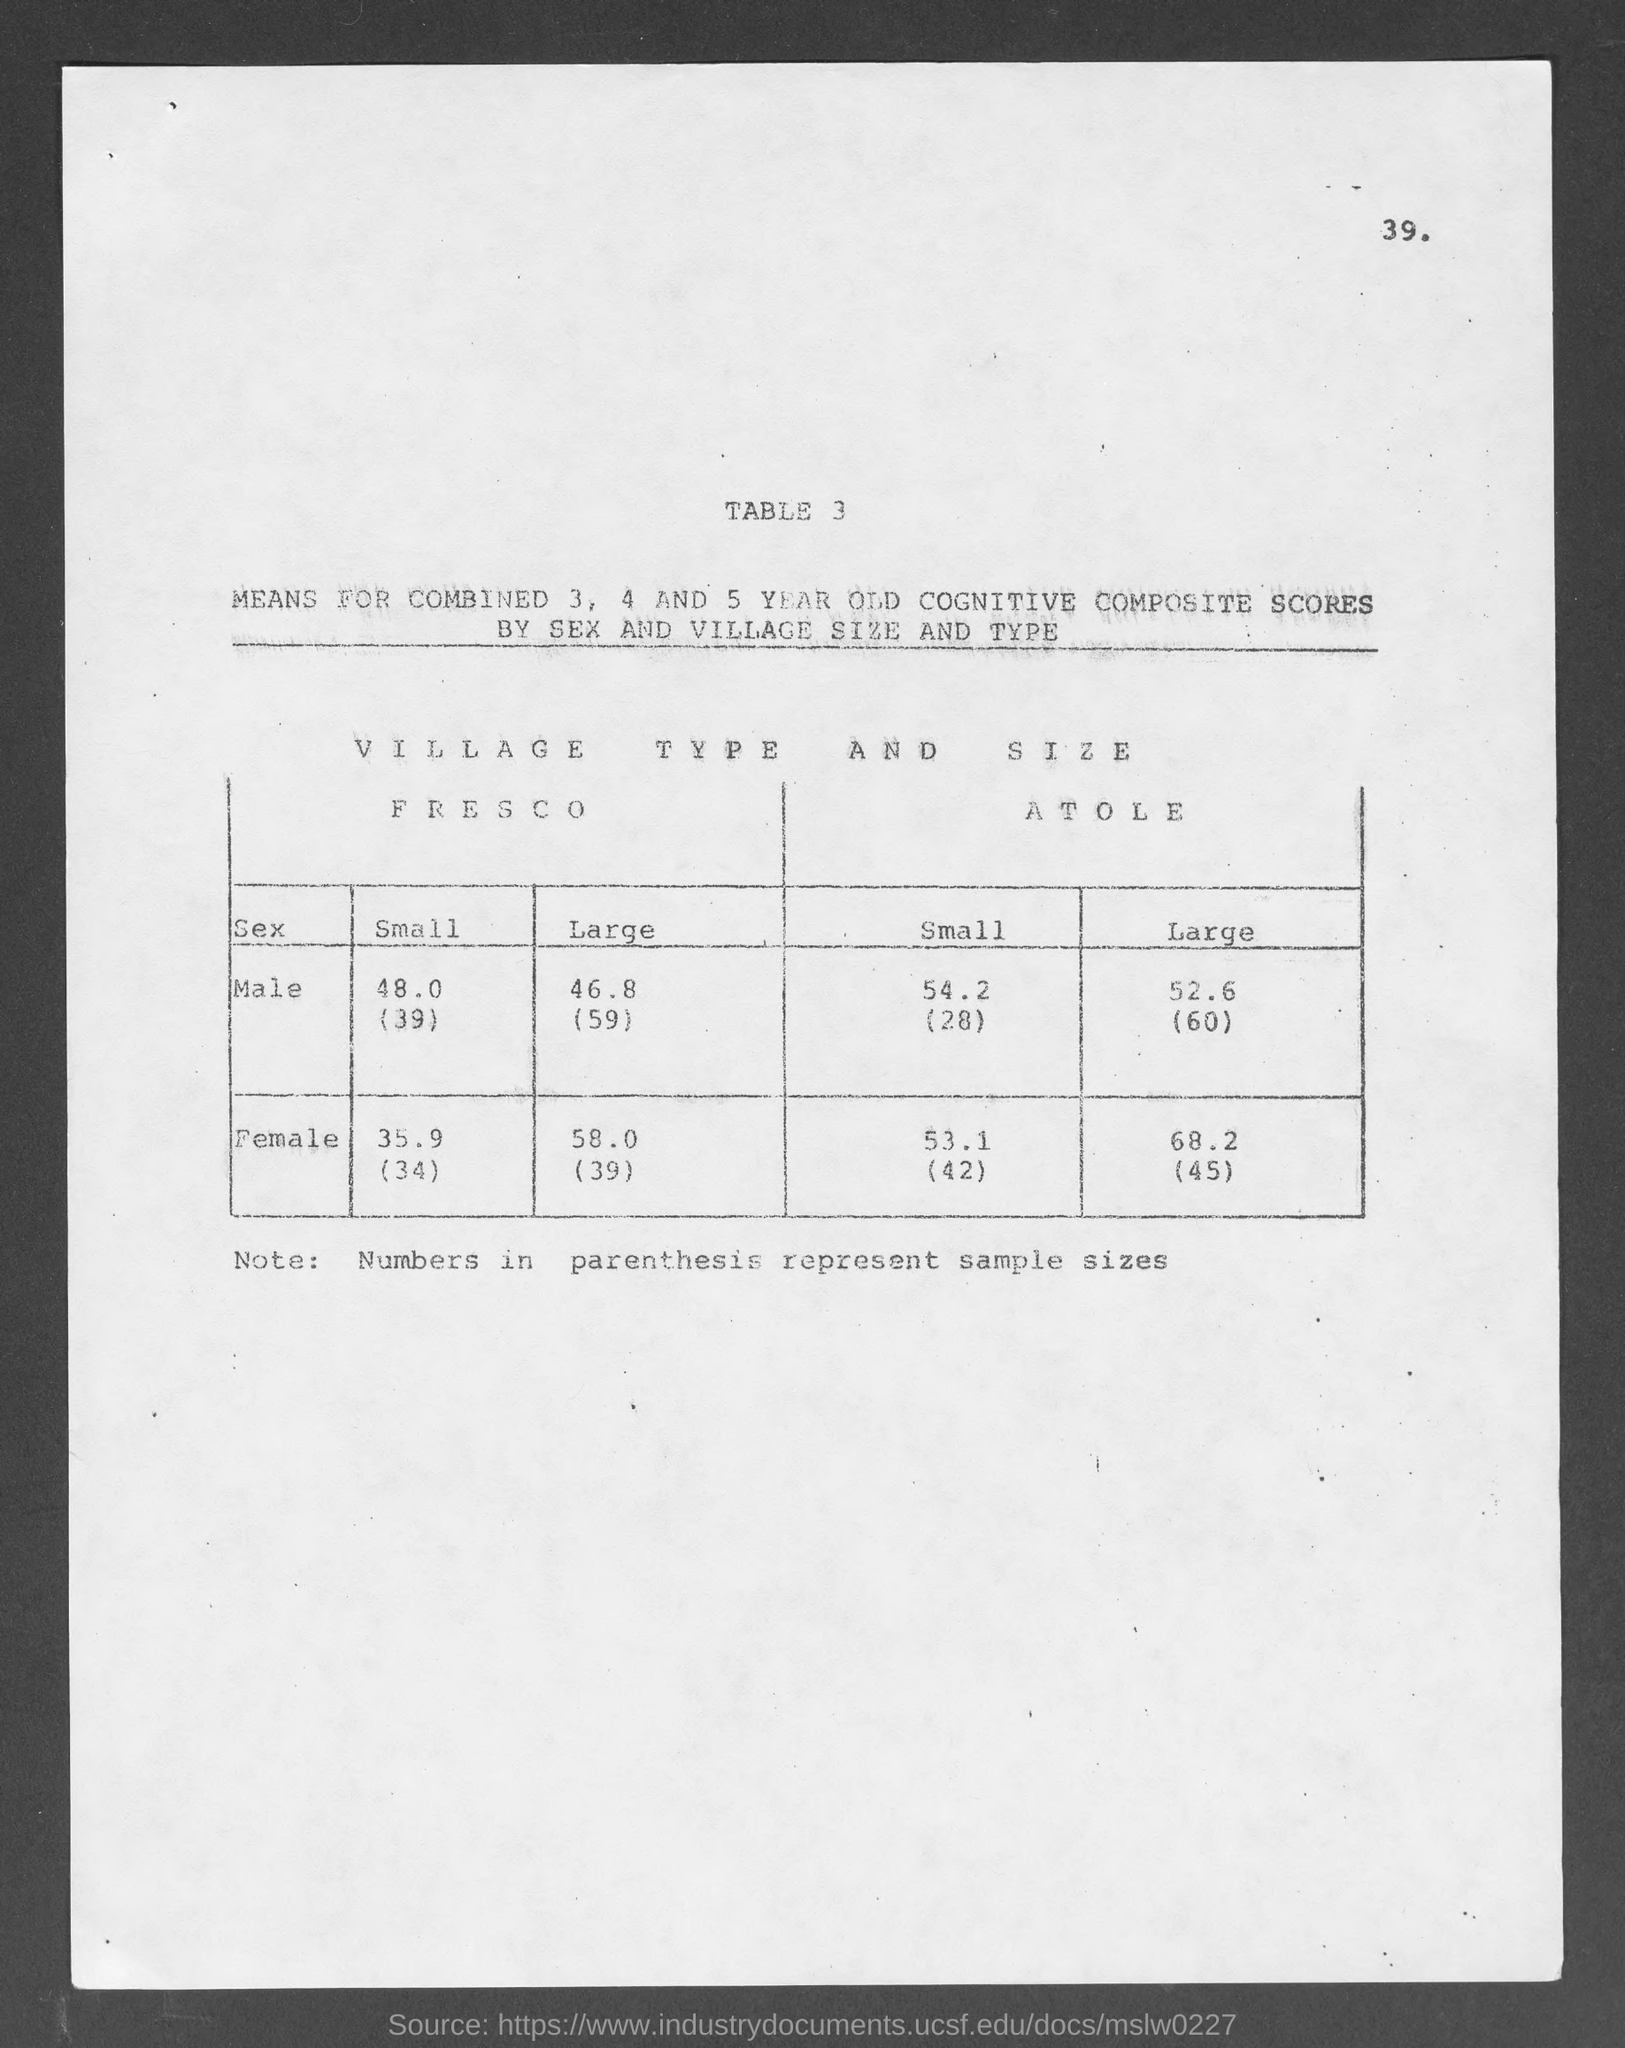What is the value of small size for male in fresco as mentioned in the given table ?
Keep it short and to the point. 48.0. What is the value of large size for male in fresco as mentioned in the given table ?
Offer a very short reply. 46.8(59). What is the value of small size for male in atole as mentioned in the given table ?
Your answer should be very brief. 54.2(28). What is the value of large size for male in atole as mentioned in the given table ?
Your answer should be compact. 52.6. What is the value of small size for female in fresco as mentioned in the given table ?
Give a very brief answer. 35.9. What is the value of large size for female in fresco as mentioned in the given table ?
Offer a terse response. 58.0. What is the value of small size for female in atole as mentioned in the given table ?
Make the answer very short. 53.1(42). What is the value of large size for female in atole as mentioned in the given table ?
Offer a terse response. 68.2. What is the note mentioned in the given page ?
Your answer should be compact. Numbers in parenthesis represent sample sizes. 